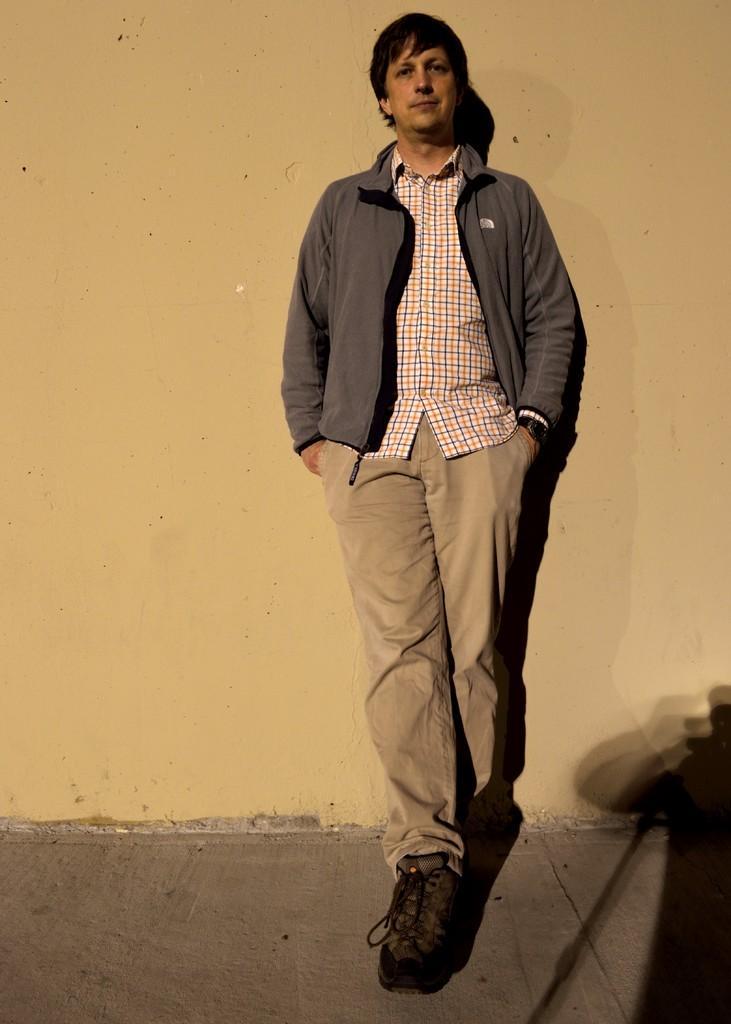In one or two sentences, can you explain what this image depicts? In this picture we can see a man wearing a jacket and he is standing. In the background we can see the wall. At the bottom portion of the picture we can see the floor. On the right side of the picture we can see the shadows. 